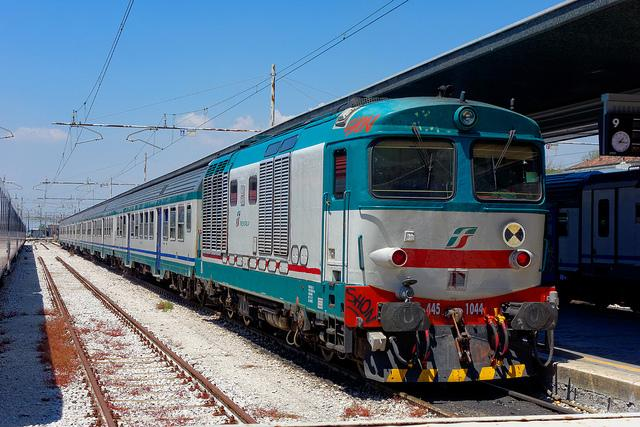What does this train carry? Please explain your reasoning. passengers. The train has passengers. 